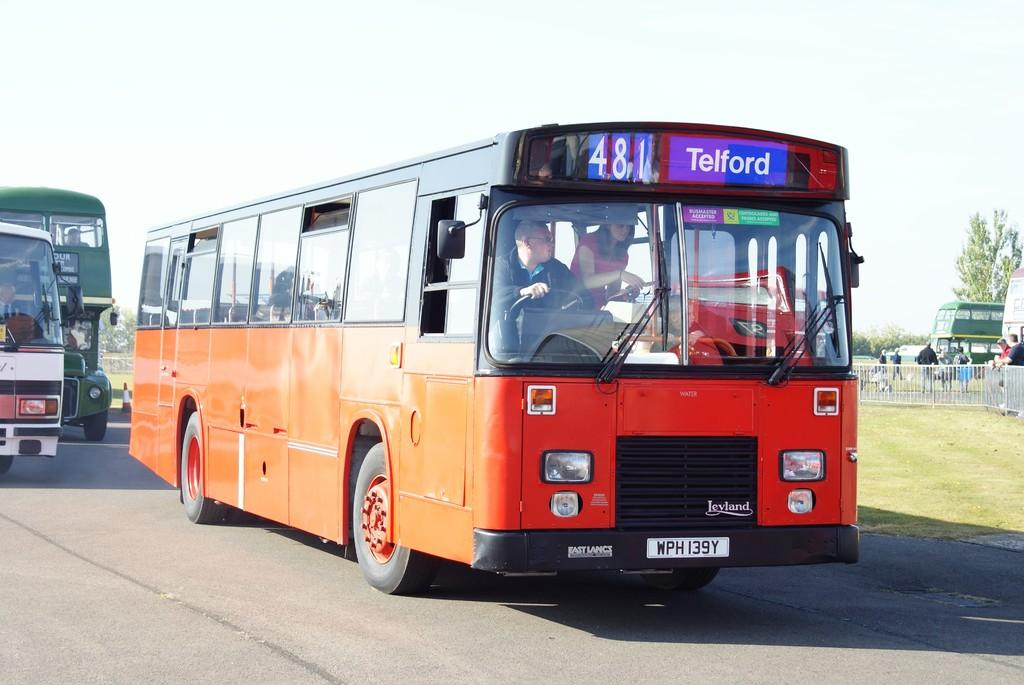<image>
Provide a brief description of the given image. A red bus on the road going to telford. 